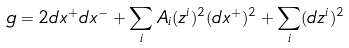<formula> <loc_0><loc_0><loc_500><loc_500>g = 2 d x ^ { + } d x ^ { - } + \sum _ { i } A _ { i } ( z ^ { i } ) ^ { 2 } ( d x ^ { + } ) ^ { 2 } + \sum _ { i } ( d z ^ { i } ) ^ { 2 }</formula> 